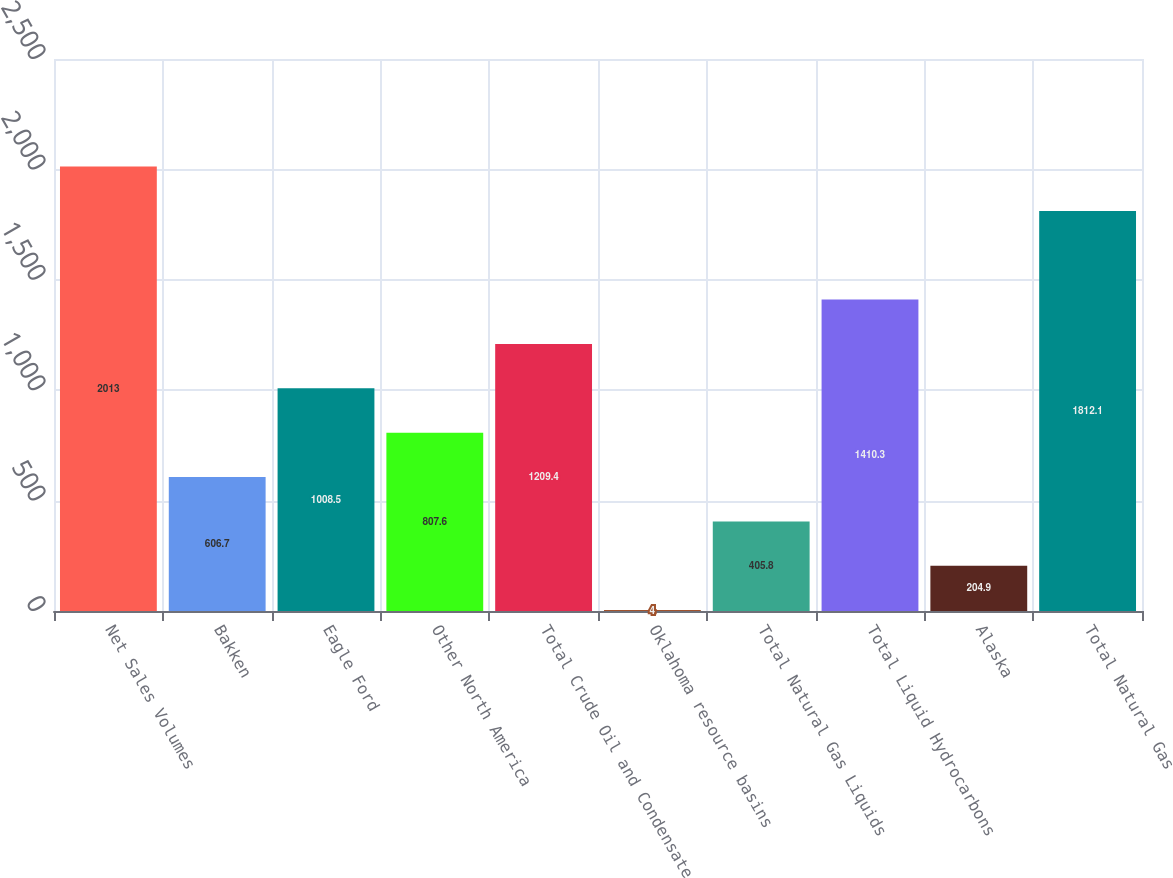Convert chart. <chart><loc_0><loc_0><loc_500><loc_500><bar_chart><fcel>Net Sales Volumes<fcel>Bakken<fcel>Eagle Ford<fcel>Other North America<fcel>Total Crude Oil and Condensate<fcel>Oklahoma resource basins<fcel>Total Natural Gas Liquids<fcel>Total Liquid Hydrocarbons<fcel>Alaska<fcel>Total Natural Gas<nl><fcel>2013<fcel>606.7<fcel>1008.5<fcel>807.6<fcel>1209.4<fcel>4<fcel>405.8<fcel>1410.3<fcel>204.9<fcel>1812.1<nl></chart> 